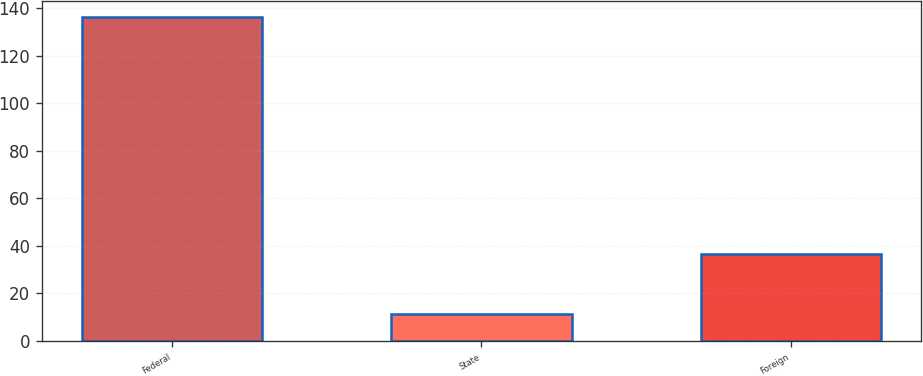<chart> <loc_0><loc_0><loc_500><loc_500><bar_chart><fcel>Federal<fcel>State<fcel>Foreign<nl><fcel>136.2<fcel>11.4<fcel>36.6<nl></chart> 